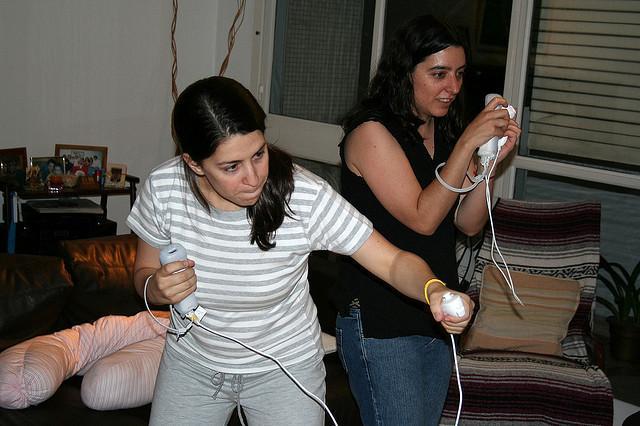What is probably in front of them?
Indicate the correct response by choosing from the four available options to answer the question.
Options: Video game, radio, laptop, computer. Video game. 